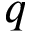Convert formula to latex. <formula><loc_0><loc_0><loc_500><loc_500>q</formula> 